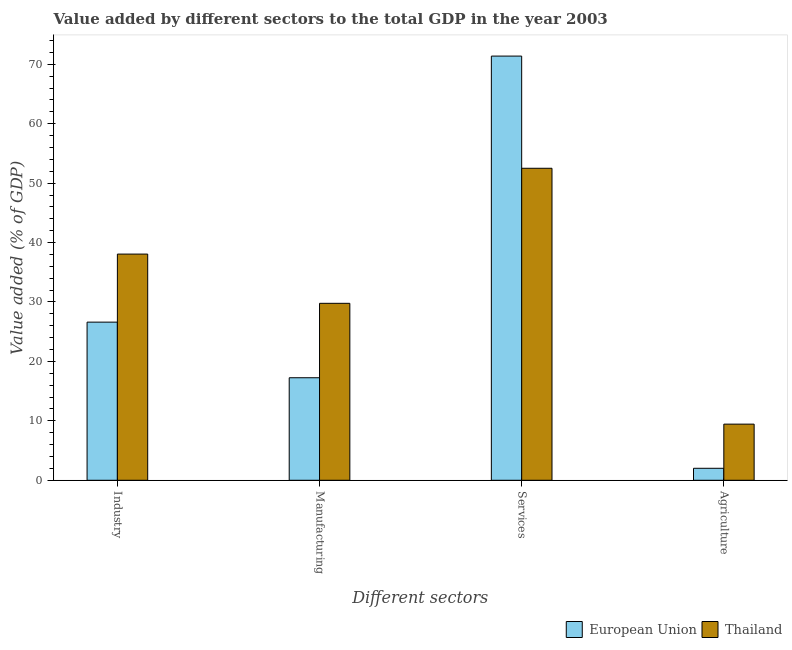How many different coloured bars are there?
Your answer should be compact. 2. How many groups of bars are there?
Your answer should be compact. 4. Are the number of bars per tick equal to the number of legend labels?
Your response must be concise. Yes. Are the number of bars on each tick of the X-axis equal?
Give a very brief answer. Yes. How many bars are there on the 3rd tick from the right?
Provide a short and direct response. 2. What is the label of the 1st group of bars from the left?
Keep it short and to the point. Industry. What is the value added by manufacturing sector in Thailand?
Provide a short and direct response. 29.77. Across all countries, what is the maximum value added by agricultural sector?
Your response must be concise. 9.44. Across all countries, what is the minimum value added by services sector?
Your response must be concise. 52.5. In which country was the value added by manufacturing sector maximum?
Offer a very short reply. Thailand. What is the total value added by industrial sector in the graph?
Ensure brevity in your answer.  64.67. What is the difference between the value added by services sector in Thailand and that in European Union?
Provide a short and direct response. -18.88. What is the difference between the value added by manufacturing sector in European Union and the value added by industrial sector in Thailand?
Give a very brief answer. -20.81. What is the average value added by agricultural sector per country?
Your answer should be very brief. 5.73. What is the difference between the value added by services sector and value added by agricultural sector in Thailand?
Make the answer very short. 43.05. What is the ratio of the value added by services sector in Thailand to that in European Union?
Give a very brief answer. 0.74. What is the difference between the highest and the second highest value added by services sector?
Your answer should be compact. 18.88. What is the difference between the highest and the lowest value added by manufacturing sector?
Provide a short and direct response. 12.52. Is the sum of the value added by manufacturing sector in Thailand and European Union greater than the maximum value added by services sector across all countries?
Keep it short and to the point. No. What does the 2nd bar from the left in Services represents?
Your answer should be compact. Thailand. What does the 2nd bar from the right in Agriculture represents?
Offer a terse response. European Union. How many bars are there?
Keep it short and to the point. 8. Are all the bars in the graph horizontal?
Provide a short and direct response. No. What is the difference between two consecutive major ticks on the Y-axis?
Ensure brevity in your answer.  10. Are the values on the major ticks of Y-axis written in scientific E-notation?
Offer a terse response. No. Does the graph contain any zero values?
Your answer should be compact. No. Does the graph contain grids?
Ensure brevity in your answer.  No. How many legend labels are there?
Provide a succinct answer. 2. How are the legend labels stacked?
Offer a very short reply. Horizontal. What is the title of the graph?
Give a very brief answer. Value added by different sectors to the total GDP in the year 2003. What is the label or title of the X-axis?
Ensure brevity in your answer.  Different sectors. What is the label or title of the Y-axis?
Ensure brevity in your answer.  Value added (% of GDP). What is the Value added (% of GDP) of European Union in Industry?
Offer a terse response. 26.61. What is the Value added (% of GDP) in Thailand in Industry?
Keep it short and to the point. 38.06. What is the Value added (% of GDP) in European Union in Manufacturing?
Your answer should be very brief. 17.25. What is the Value added (% of GDP) of Thailand in Manufacturing?
Offer a very short reply. 29.77. What is the Value added (% of GDP) of European Union in Services?
Offer a very short reply. 71.38. What is the Value added (% of GDP) in Thailand in Services?
Provide a short and direct response. 52.5. What is the Value added (% of GDP) in European Union in Agriculture?
Your answer should be compact. 2.02. What is the Value added (% of GDP) in Thailand in Agriculture?
Your answer should be compact. 9.44. Across all Different sectors, what is the maximum Value added (% of GDP) of European Union?
Provide a short and direct response. 71.38. Across all Different sectors, what is the maximum Value added (% of GDP) in Thailand?
Your answer should be compact. 52.5. Across all Different sectors, what is the minimum Value added (% of GDP) of European Union?
Offer a very short reply. 2.02. Across all Different sectors, what is the minimum Value added (% of GDP) of Thailand?
Provide a short and direct response. 9.44. What is the total Value added (% of GDP) in European Union in the graph?
Provide a succinct answer. 117.25. What is the total Value added (% of GDP) of Thailand in the graph?
Offer a very short reply. 129.77. What is the difference between the Value added (% of GDP) of European Union in Industry and that in Manufacturing?
Give a very brief answer. 9.36. What is the difference between the Value added (% of GDP) of Thailand in Industry and that in Manufacturing?
Your answer should be compact. 8.28. What is the difference between the Value added (% of GDP) in European Union in Industry and that in Services?
Offer a very short reply. -44.77. What is the difference between the Value added (% of GDP) in Thailand in Industry and that in Services?
Offer a terse response. -14.44. What is the difference between the Value added (% of GDP) of European Union in Industry and that in Agriculture?
Your answer should be compact. 24.59. What is the difference between the Value added (% of GDP) in Thailand in Industry and that in Agriculture?
Give a very brief answer. 28.61. What is the difference between the Value added (% of GDP) of European Union in Manufacturing and that in Services?
Keep it short and to the point. -54.12. What is the difference between the Value added (% of GDP) in Thailand in Manufacturing and that in Services?
Provide a succinct answer. -22.72. What is the difference between the Value added (% of GDP) in European Union in Manufacturing and that in Agriculture?
Make the answer very short. 15.24. What is the difference between the Value added (% of GDP) of Thailand in Manufacturing and that in Agriculture?
Make the answer very short. 20.33. What is the difference between the Value added (% of GDP) of European Union in Services and that in Agriculture?
Ensure brevity in your answer.  69.36. What is the difference between the Value added (% of GDP) in Thailand in Services and that in Agriculture?
Make the answer very short. 43.05. What is the difference between the Value added (% of GDP) of European Union in Industry and the Value added (% of GDP) of Thailand in Manufacturing?
Keep it short and to the point. -3.16. What is the difference between the Value added (% of GDP) of European Union in Industry and the Value added (% of GDP) of Thailand in Services?
Ensure brevity in your answer.  -25.89. What is the difference between the Value added (% of GDP) of European Union in Industry and the Value added (% of GDP) of Thailand in Agriculture?
Your answer should be compact. 17.16. What is the difference between the Value added (% of GDP) in European Union in Manufacturing and the Value added (% of GDP) in Thailand in Services?
Keep it short and to the point. -35.25. What is the difference between the Value added (% of GDP) in European Union in Manufacturing and the Value added (% of GDP) in Thailand in Agriculture?
Offer a terse response. 7.81. What is the difference between the Value added (% of GDP) in European Union in Services and the Value added (% of GDP) in Thailand in Agriculture?
Keep it short and to the point. 61.93. What is the average Value added (% of GDP) in European Union per Different sectors?
Give a very brief answer. 29.31. What is the average Value added (% of GDP) in Thailand per Different sectors?
Your answer should be very brief. 32.44. What is the difference between the Value added (% of GDP) of European Union and Value added (% of GDP) of Thailand in Industry?
Keep it short and to the point. -11.45. What is the difference between the Value added (% of GDP) of European Union and Value added (% of GDP) of Thailand in Manufacturing?
Your answer should be compact. -12.52. What is the difference between the Value added (% of GDP) in European Union and Value added (% of GDP) in Thailand in Services?
Keep it short and to the point. 18.88. What is the difference between the Value added (% of GDP) of European Union and Value added (% of GDP) of Thailand in Agriculture?
Your answer should be compact. -7.43. What is the ratio of the Value added (% of GDP) of European Union in Industry to that in Manufacturing?
Keep it short and to the point. 1.54. What is the ratio of the Value added (% of GDP) of Thailand in Industry to that in Manufacturing?
Your answer should be very brief. 1.28. What is the ratio of the Value added (% of GDP) of European Union in Industry to that in Services?
Your response must be concise. 0.37. What is the ratio of the Value added (% of GDP) in Thailand in Industry to that in Services?
Provide a short and direct response. 0.72. What is the ratio of the Value added (% of GDP) in European Union in Industry to that in Agriculture?
Your response must be concise. 13.21. What is the ratio of the Value added (% of GDP) in Thailand in Industry to that in Agriculture?
Provide a short and direct response. 4.03. What is the ratio of the Value added (% of GDP) in European Union in Manufacturing to that in Services?
Ensure brevity in your answer.  0.24. What is the ratio of the Value added (% of GDP) in Thailand in Manufacturing to that in Services?
Keep it short and to the point. 0.57. What is the ratio of the Value added (% of GDP) in European Union in Manufacturing to that in Agriculture?
Keep it short and to the point. 8.56. What is the ratio of the Value added (% of GDP) in Thailand in Manufacturing to that in Agriculture?
Offer a very short reply. 3.15. What is the ratio of the Value added (% of GDP) of European Union in Services to that in Agriculture?
Provide a succinct answer. 35.42. What is the ratio of the Value added (% of GDP) of Thailand in Services to that in Agriculture?
Your answer should be compact. 5.56. What is the difference between the highest and the second highest Value added (% of GDP) in European Union?
Make the answer very short. 44.77. What is the difference between the highest and the second highest Value added (% of GDP) of Thailand?
Offer a terse response. 14.44. What is the difference between the highest and the lowest Value added (% of GDP) in European Union?
Provide a short and direct response. 69.36. What is the difference between the highest and the lowest Value added (% of GDP) in Thailand?
Offer a very short reply. 43.05. 